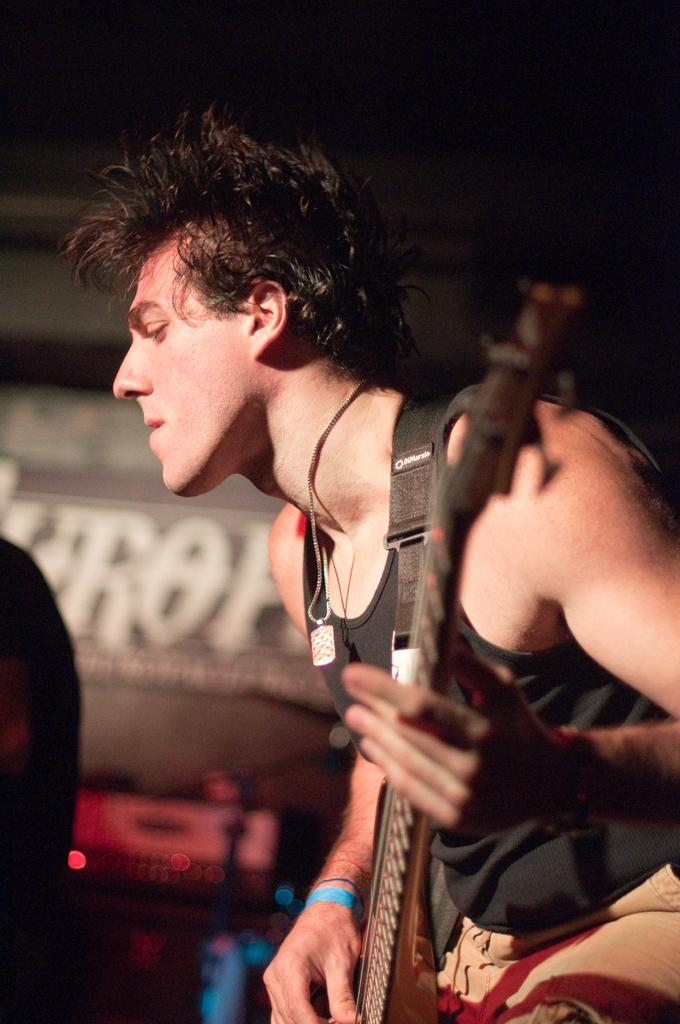What is the main subject of the image? There is a person in the image. What is the person holding in the image? The person is holding a guitar. How many crates are visible in the image? There are no crates present in the image. What type of point is the person making in the image? There is no indication of the person making a point in the image, as they are holding a guitar. 